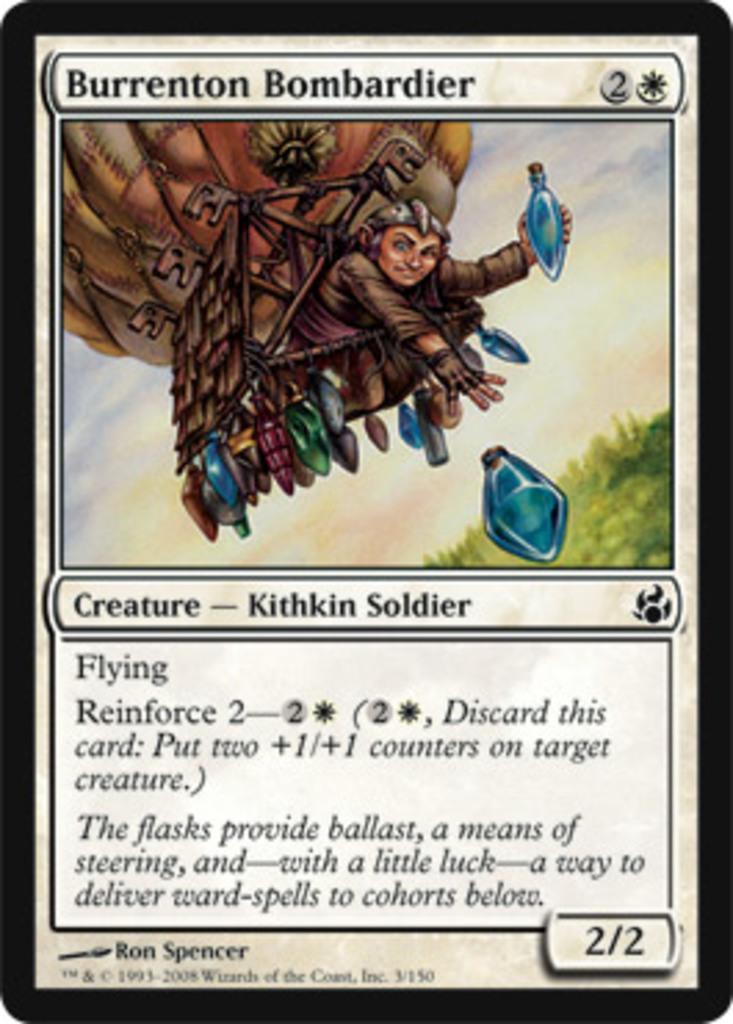Describe this image in one or two sentences. In this image I can see an animated picture in which the person is in the hot air balloon and the person is holding something. I can see the sky, grass and something is written on it. 